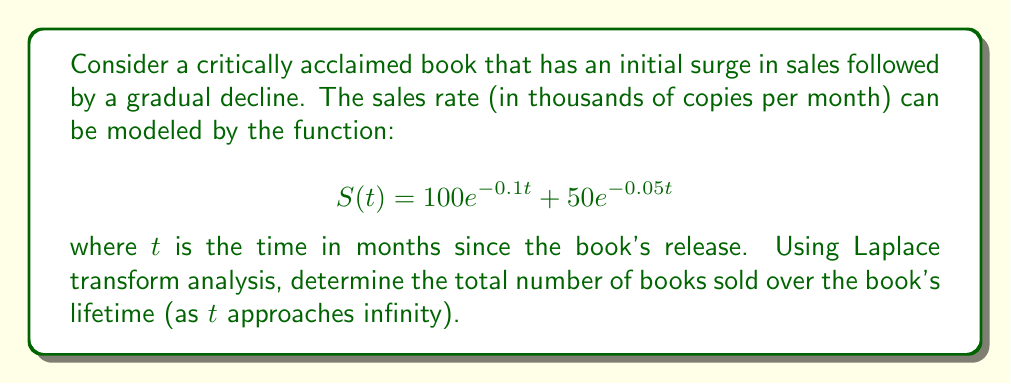Provide a solution to this math problem. To solve this problem, we'll use the following steps:

1) First, we need to find the Laplace transform of $S(t)$. The Laplace transform of $ae^{-bt}$ is $\frac{a}{s+b}$.

2) The Laplace transform of $S(t)$ is:

   $$\mathcal{L}\{S(t)\} = \frac{100}{s+0.1} + \frac{50}{s+0.05}$$

3) To find the total number of books sold over the lifetime, we need to integrate $S(t)$ from 0 to infinity. In the Laplace domain, this is equivalent to evaluating $\mathcal{L}\{S(t)\}$ at $s=0$.

4) Let's call the total number of books sold $N$:

   $$N = \lim_{s \to 0} s\mathcal{L}\{S(t)\} = \lim_{s \to 0} s\left(\frac{100}{s+0.1} + \frac{50}{s+0.05}\right)$$

5) Evaluating this limit:

   $$N = 100\lim_{s \to 0} \frac{s}{s+0.1} + 50\lim_{s \to 0} \frac{s}{s+0.05}$$

   $$N = 100 \cdot 1 + 50 \cdot 1 = 1000 + 1000 = 2000$$

6) Therefore, the total number of books sold over the book's lifetime is 2000 thousand, or 2 million copies.
Answer: The total number of books sold over the book's lifetime is 2 million copies. 